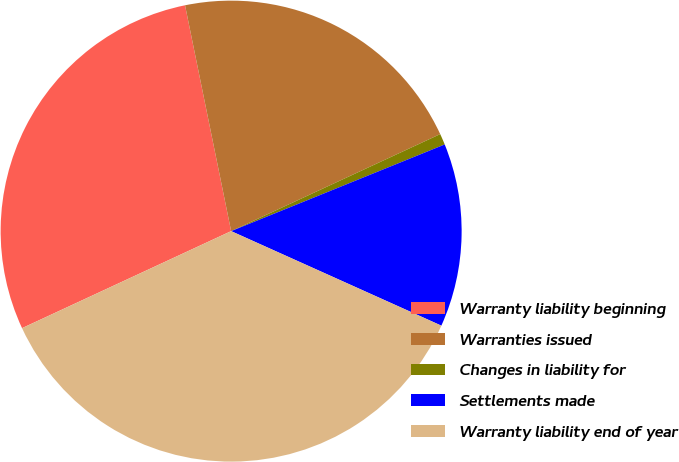Convert chart. <chart><loc_0><loc_0><loc_500><loc_500><pie_chart><fcel>Warranty liability beginning<fcel>Warranties issued<fcel>Changes in liability for<fcel>Settlements made<fcel>Warranty liability end of year<nl><fcel>28.71%<fcel>21.29%<fcel>0.78%<fcel>12.86%<fcel>36.36%<nl></chart> 